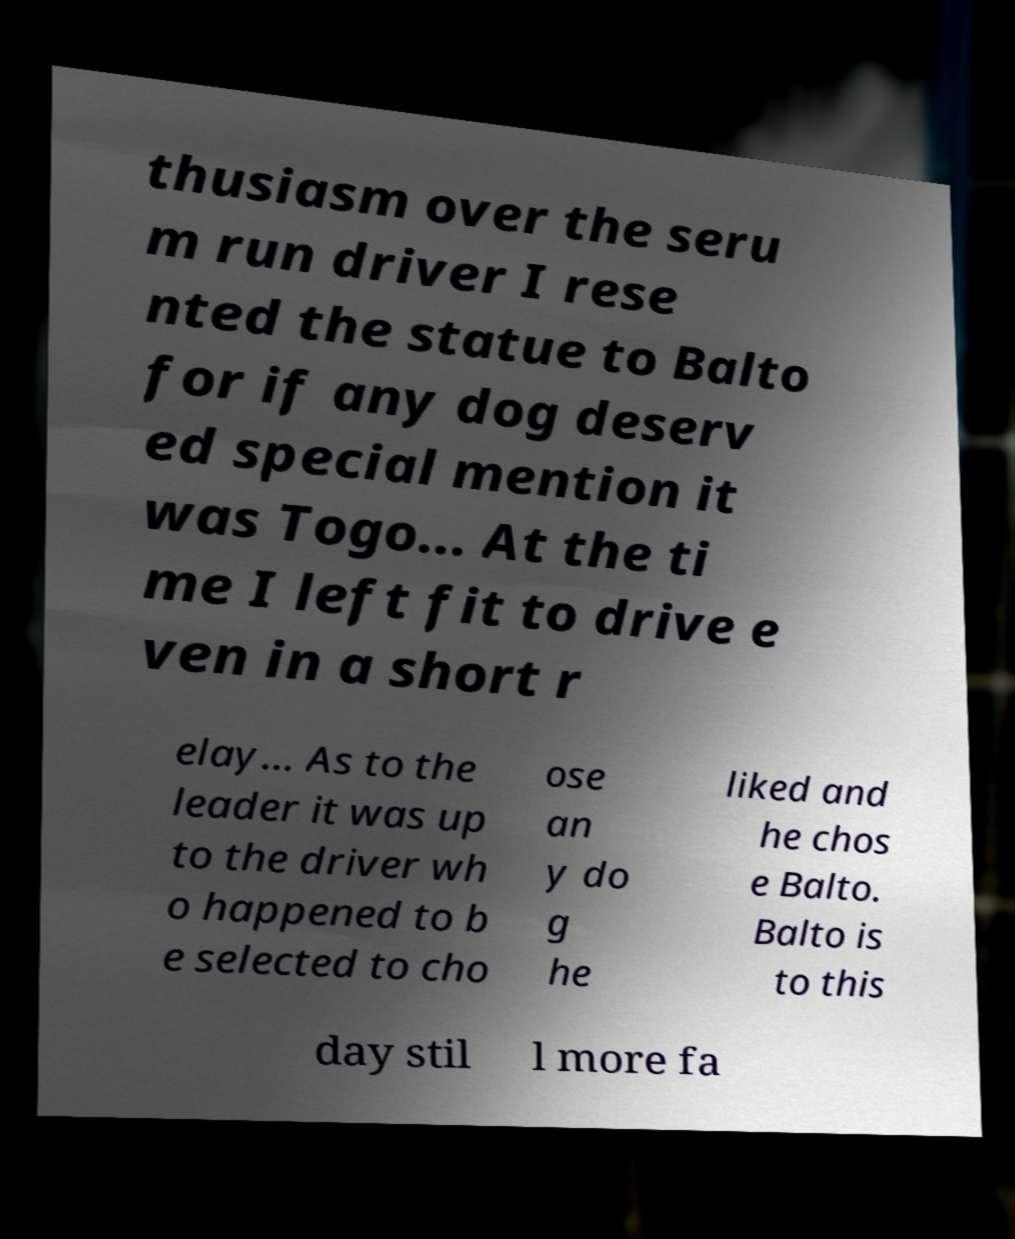Could you assist in decoding the text presented in this image and type it out clearly? thusiasm over the seru m run driver I rese nted the statue to Balto for if any dog deserv ed special mention it was Togo... At the ti me I left fit to drive e ven in a short r elay... As to the leader it was up to the driver wh o happened to b e selected to cho ose an y do g he liked and he chos e Balto. Balto is to this day stil l more fa 